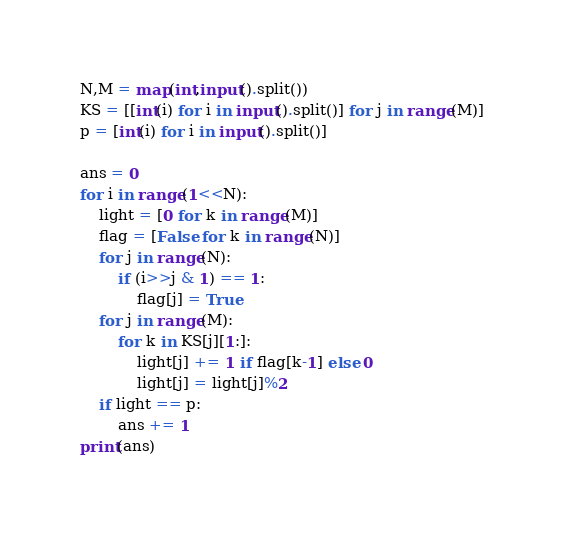Convert code to text. <code><loc_0><loc_0><loc_500><loc_500><_Python_>N,M = map(int,input().split())
KS = [[int(i) for i in input().split()] for j in range(M)]
p = [int(i) for i in input().split()]

ans = 0
for i in range(1<<N):
    light = [0 for k in range(M)]
    flag = [False for k in range(N)]
    for j in range(N):
        if (i>>j & 1) == 1:
            flag[j] = True
    for j in range(M):
        for k in KS[j][1:]:
            light[j] += 1 if flag[k-1] else 0
            light[j] = light[j]%2
    if light == p:
        ans += 1
print(ans)</code> 